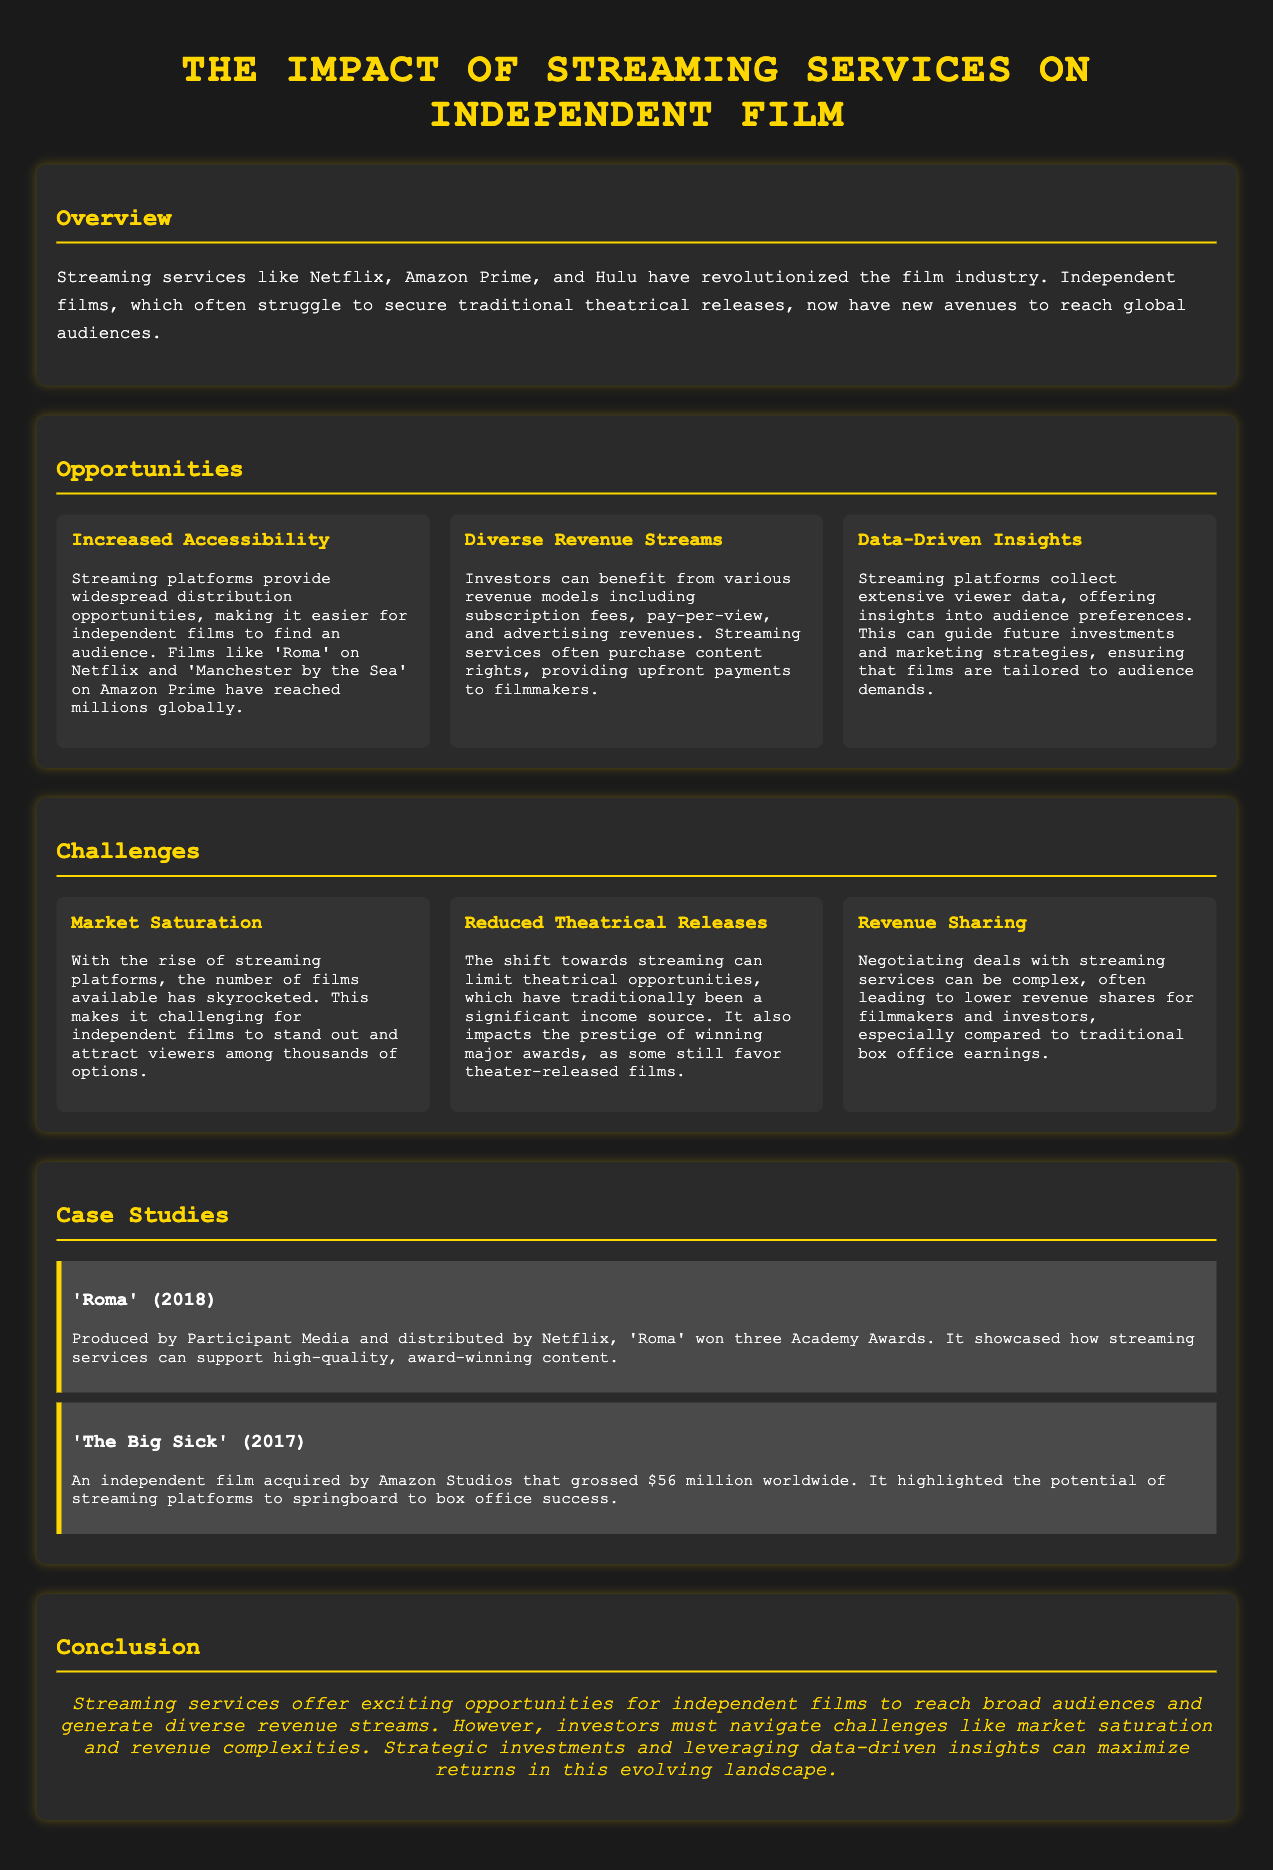What is the title of the infographic? The title is displayed prominently at the center of the document.
Answer: The Impact of Streaming Services on Independent Film What film won three Academy Awards? This information is found under the case studies section on 'Roma'.
Answer: Roma Which streaming service distributed 'The Big Sick'? The case study section mentions the distribution details for 'The Big Sick'.
Answer: Amazon Studios What is one opportunity mentioned for independent films? This information can be found under the Opportunities section as one of the challenges faced by independent films.
Answer: Increased Accessibility What is a main challenge faced by independent films according to the document? This is identified under the Challenges section, prompting the need for detail from that part of the infographic.
Answer: Market Saturation What year was 'Roma' released? The year is included in the case study section for the film 'Roma'.
Answer: 2018 How much did 'The Big Sick' gross worldwide? This figure is listed in the case study section for the film 'The Big Sick'.
Answer: $56 million What color is used for the section headings? The document specifies the color consistently used for section headings throughout the infographic.
Answer: Gold What does the conclusion emphasize about strategic investments? The conclusion outlines a specific recommendation for investors towards concluding advice.
Answer: Maximize returns 